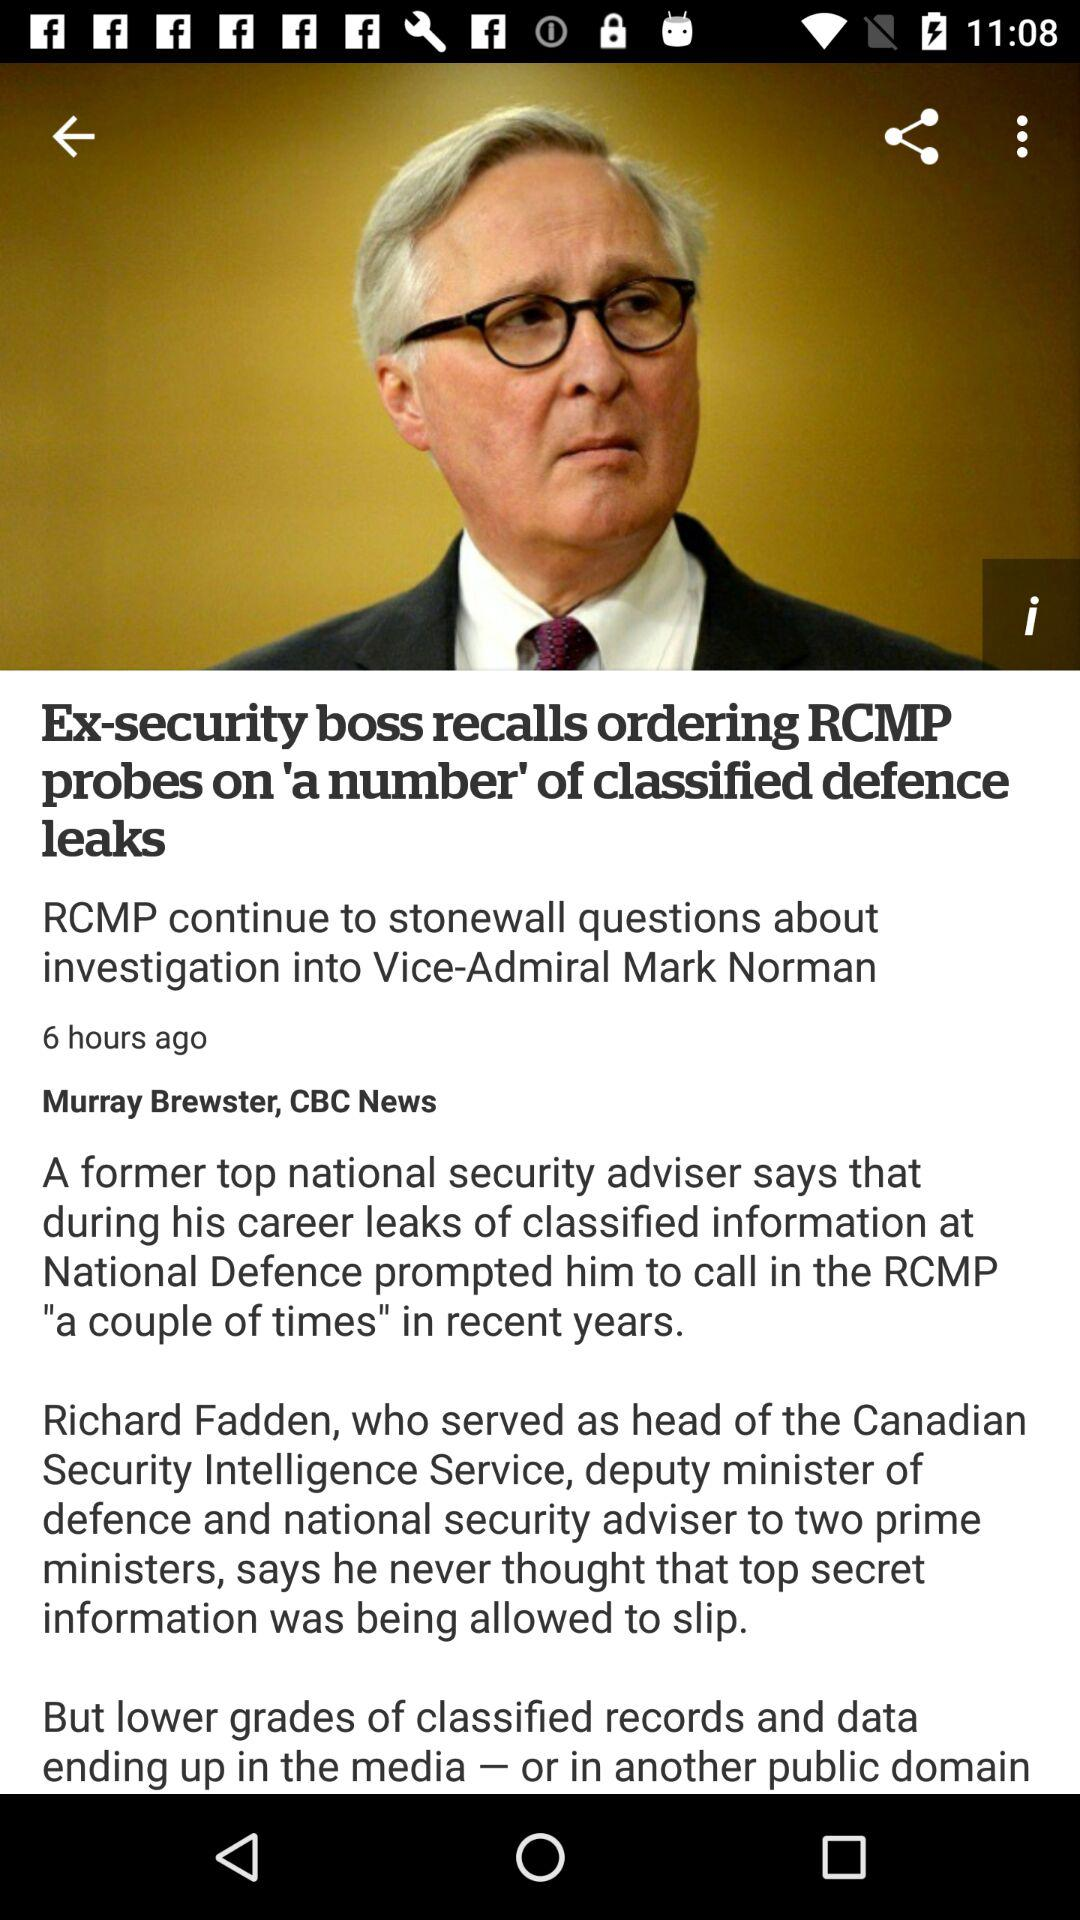How many times has the RCMP been called in to investigate leaks?
Answer the question using a single word or phrase. A couple of times 